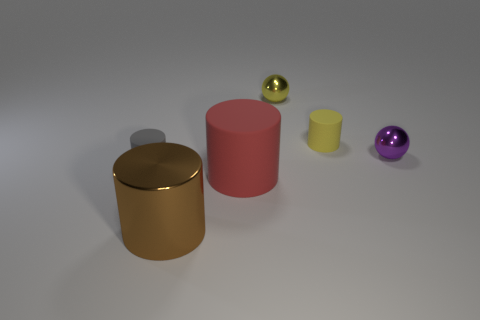There is a purple metal thing behind the rubber cylinder in front of the gray object; what is its size?
Keep it short and to the point. Small. The cylinder that is both to the right of the brown metallic cylinder and left of the yellow ball is what color?
Offer a terse response. Red. What number of other things are the same size as the yellow sphere?
Your answer should be compact. 3. There is a yellow matte cylinder; is it the same size as the shiny object behind the tiny purple shiny sphere?
Ensure brevity in your answer.  Yes. There is a rubber thing that is the same size as the metallic cylinder; what color is it?
Ensure brevity in your answer.  Red. The purple ball is what size?
Provide a short and direct response. Small. Does the tiny thing left of the small yellow shiny thing have the same material as the brown object?
Provide a short and direct response. No. Is the shape of the red object the same as the small yellow metal thing?
Offer a terse response. No. What shape is the shiny object to the right of the small matte thing right of the cylinder that is left of the metallic cylinder?
Make the answer very short. Sphere. There is a matte object that is behind the tiny gray object; is it the same shape as the red thing in front of the yellow rubber cylinder?
Ensure brevity in your answer.  Yes. 